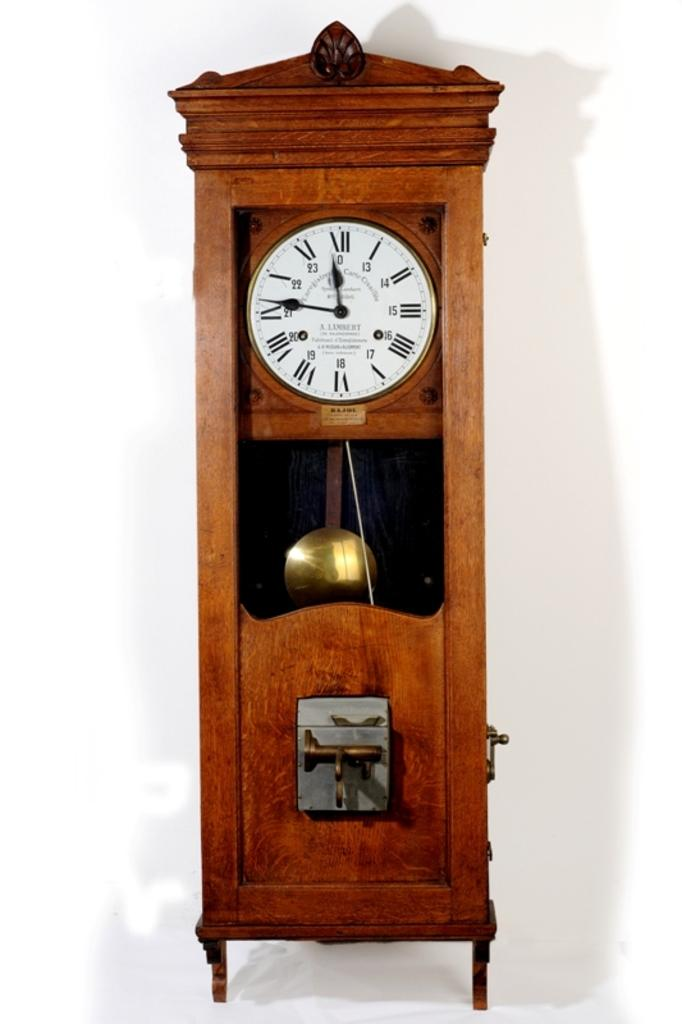<image>
Render a clear and concise summary of the photo. A A. Lambert brand grandfather clock showing the time to be approximately 11:46. 